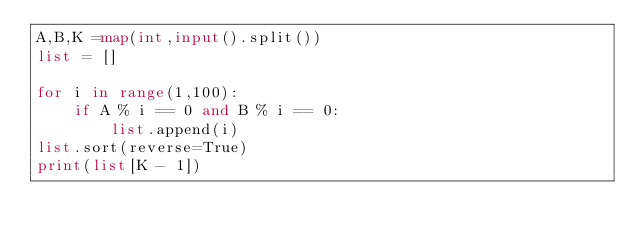<code> <loc_0><loc_0><loc_500><loc_500><_Python_>A,B,K =map(int,input().split())
list = []

for i in range(1,100):
    if A % i == 0 and B % i == 0:
        list.append(i)
list.sort(reverse=True)
print(list[K - 1])</code> 